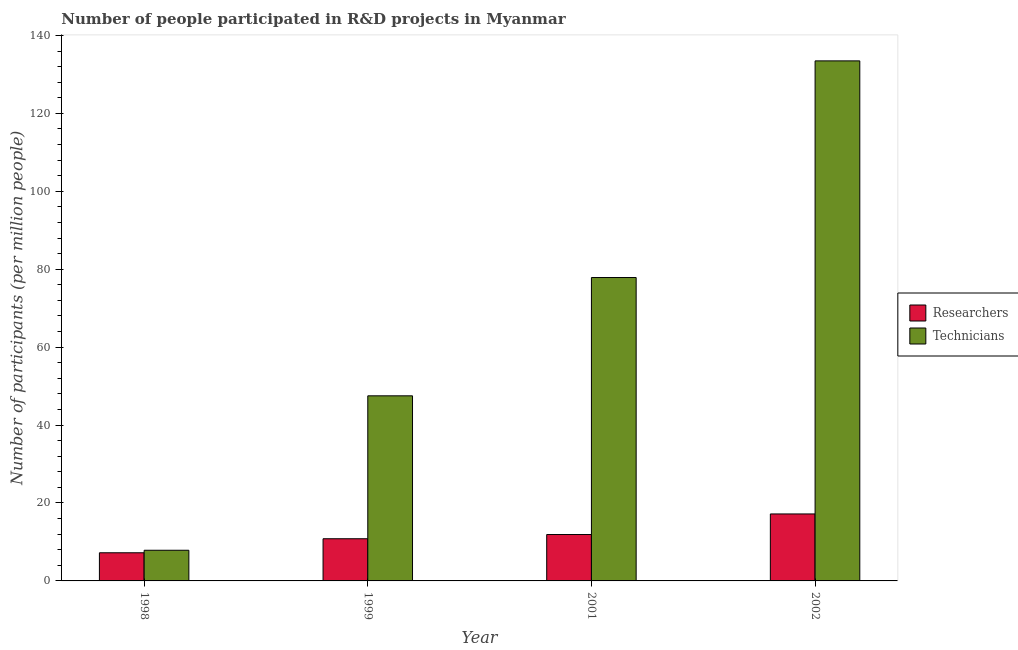How many different coloured bars are there?
Give a very brief answer. 2. Are the number of bars on each tick of the X-axis equal?
Your answer should be very brief. Yes. How many bars are there on the 2nd tick from the right?
Provide a short and direct response. 2. What is the label of the 1st group of bars from the left?
Provide a short and direct response. 1998. What is the number of technicians in 2002?
Ensure brevity in your answer.  133.48. Across all years, what is the maximum number of technicians?
Your response must be concise. 133.48. Across all years, what is the minimum number of technicians?
Your answer should be compact. 7.87. What is the total number of technicians in the graph?
Offer a very short reply. 266.73. What is the difference between the number of researchers in 1998 and that in 1999?
Ensure brevity in your answer.  -3.6. What is the difference between the number of researchers in 2001 and the number of technicians in 2002?
Make the answer very short. -5.28. What is the average number of technicians per year?
Make the answer very short. 66.68. In how many years, is the number of researchers greater than 124?
Provide a succinct answer. 0. What is the ratio of the number of technicians in 1998 to that in 2001?
Your answer should be very brief. 0.1. Is the number of technicians in 1998 less than that in 1999?
Offer a very short reply. Yes. What is the difference between the highest and the second highest number of technicians?
Offer a terse response. 55.61. What is the difference between the highest and the lowest number of technicians?
Offer a terse response. 125.61. What does the 1st bar from the left in 2002 represents?
Provide a short and direct response. Researchers. What does the 2nd bar from the right in 1998 represents?
Your answer should be compact. Researchers. How many bars are there?
Keep it short and to the point. 8. How many years are there in the graph?
Make the answer very short. 4. Does the graph contain any zero values?
Make the answer very short. No. Where does the legend appear in the graph?
Provide a short and direct response. Center right. How many legend labels are there?
Your response must be concise. 2. How are the legend labels stacked?
Your response must be concise. Vertical. What is the title of the graph?
Give a very brief answer. Number of people participated in R&D projects in Myanmar. What is the label or title of the Y-axis?
Ensure brevity in your answer.  Number of participants (per million people). What is the Number of participants (per million people) in Researchers in 1998?
Make the answer very short. 7.22. What is the Number of participants (per million people) of Technicians in 1998?
Keep it short and to the point. 7.87. What is the Number of participants (per million people) of Researchers in 1999?
Give a very brief answer. 10.83. What is the Number of participants (per million people) in Technicians in 1999?
Make the answer very short. 47.51. What is the Number of participants (per million people) of Researchers in 2001?
Your answer should be compact. 11.91. What is the Number of participants (per million people) of Technicians in 2001?
Make the answer very short. 77.87. What is the Number of participants (per million people) of Researchers in 2002?
Your response must be concise. 17.19. What is the Number of participants (per million people) of Technicians in 2002?
Your answer should be very brief. 133.48. Across all years, what is the maximum Number of participants (per million people) in Researchers?
Your answer should be very brief. 17.19. Across all years, what is the maximum Number of participants (per million people) in Technicians?
Offer a terse response. 133.48. Across all years, what is the minimum Number of participants (per million people) of Researchers?
Ensure brevity in your answer.  7.22. Across all years, what is the minimum Number of participants (per million people) in Technicians?
Offer a terse response. 7.87. What is the total Number of participants (per million people) of Researchers in the graph?
Your response must be concise. 47.15. What is the total Number of participants (per million people) in Technicians in the graph?
Provide a short and direct response. 266.73. What is the difference between the Number of participants (per million people) in Researchers in 1998 and that in 1999?
Provide a succinct answer. -3.6. What is the difference between the Number of participants (per million people) in Technicians in 1998 and that in 1999?
Ensure brevity in your answer.  -39.64. What is the difference between the Number of participants (per million people) in Researchers in 1998 and that in 2001?
Offer a very short reply. -4.69. What is the difference between the Number of participants (per million people) in Technicians in 1998 and that in 2001?
Keep it short and to the point. -70. What is the difference between the Number of participants (per million people) of Researchers in 1998 and that in 2002?
Your answer should be very brief. -9.97. What is the difference between the Number of participants (per million people) of Technicians in 1998 and that in 2002?
Ensure brevity in your answer.  -125.61. What is the difference between the Number of participants (per million people) in Researchers in 1999 and that in 2001?
Make the answer very short. -1.08. What is the difference between the Number of participants (per million people) of Technicians in 1999 and that in 2001?
Your response must be concise. -30.36. What is the difference between the Number of participants (per million people) in Researchers in 1999 and that in 2002?
Your answer should be very brief. -6.36. What is the difference between the Number of participants (per million people) of Technicians in 1999 and that in 2002?
Your response must be concise. -85.97. What is the difference between the Number of participants (per million people) in Researchers in 2001 and that in 2002?
Make the answer very short. -5.28. What is the difference between the Number of participants (per million people) in Technicians in 2001 and that in 2002?
Your response must be concise. -55.61. What is the difference between the Number of participants (per million people) of Researchers in 1998 and the Number of participants (per million people) of Technicians in 1999?
Provide a short and direct response. -40.28. What is the difference between the Number of participants (per million people) in Researchers in 1998 and the Number of participants (per million people) in Technicians in 2001?
Ensure brevity in your answer.  -70.65. What is the difference between the Number of participants (per million people) in Researchers in 1998 and the Number of participants (per million people) in Technicians in 2002?
Provide a succinct answer. -126.25. What is the difference between the Number of participants (per million people) in Researchers in 1999 and the Number of participants (per million people) in Technicians in 2001?
Make the answer very short. -67.04. What is the difference between the Number of participants (per million people) in Researchers in 1999 and the Number of participants (per million people) in Technicians in 2002?
Your response must be concise. -122.65. What is the difference between the Number of participants (per million people) of Researchers in 2001 and the Number of participants (per million people) of Technicians in 2002?
Offer a terse response. -121.57. What is the average Number of participants (per million people) in Researchers per year?
Provide a succinct answer. 11.79. What is the average Number of participants (per million people) in Technicians per year?
Your answer should be very brief. 66.68. In the year 1998, what is the difference between the Number of participants (per million people) of Researchers and Number of participants (per million people) of Technicians?
Ensure brevity in your answer.  -0.65. In the year 1999, what is the difference between the Number of participants (per million people) in Researchers and Number of participants (per million people) in Technicians?
Your response must be concise. -36.68. In the year 2001, what is the difference between the Number of participants (per million people) in Researchers and Number of participants (per million people) in Technicians?
Your answer should be compact. -65.96. In the year 2002, what is the difference between the Number of participants (per million people) in Researchers and Number of participants (per million people) in Technicians?
Provide a succinct answer. -116.29. What is the ratio of the Number of participants (per million people) of Researchers in 1998 to that in 1999?
Ensure brevity in your answer.  0.67. What is the ratio of the Number of participants (per million people) in Technicians in 1998 to that in 1999?
Offer a very short reply. 0.17. What is the ratio of the Number of participants (per million people) in Researchers in 1998 to that in 2001?
Make the answer very short. 0.61. What is the ratio of the Number of participants (per million people) in Technicians in 1998 to that in 2001?
Give a very brief answer. 0.1. What is the ratio of the Number of participants (per million people) in Researchers in 1998 to that in 2002?
Give a very brief answer. 0.42. What is the ratio of the Number of participants (per million people) in Technicians in 1998 to that in 2002?
Offer a terse response. 0.06. What is the ratio of the Number of participants (per million people) of Researchers in 1999 to that in 2001?
Offer a very short reply. 0.91. What is the ratio of the Number of participants (per million people) in Technicians in 1999 to that in 2001?
Your answer should be compact. 0.61. What is the ratio of the Number of participants (per million people) of Researchers in 1999 to that in 2002?
Ensure brevity in your answer.  0.63. What is the ratio of the Number of participants (per million people) in Technicians in 1999 to that in 2002?
Offer a terse response. 0.36. What is the ratio of the Number of participants (per million people) in Researchers in 2001 to that in 2002?
Give a very brief answer. 0.69. What is the ratio of the Number of participants (per million people) of Technicians in 2001 to that in 2002?
Your response must be concise. 0.58. What is the difference between the highest and the second highest Number of participants (per million people) in Researchers?
Give a very brief answer. 5.28. What is the difference between the highest and the second highest Number of participants (per million people) in Technicians?
Your response must be concise. 55.61. What is the difference between the highest and the lowest Number of participants (per million people) in Researchers?
Make the answer very short. 9.97. What is the difference between the highest and the lowest Number of participants (per million people) of Technicians?
Provide a succinct answer. 125.61. 